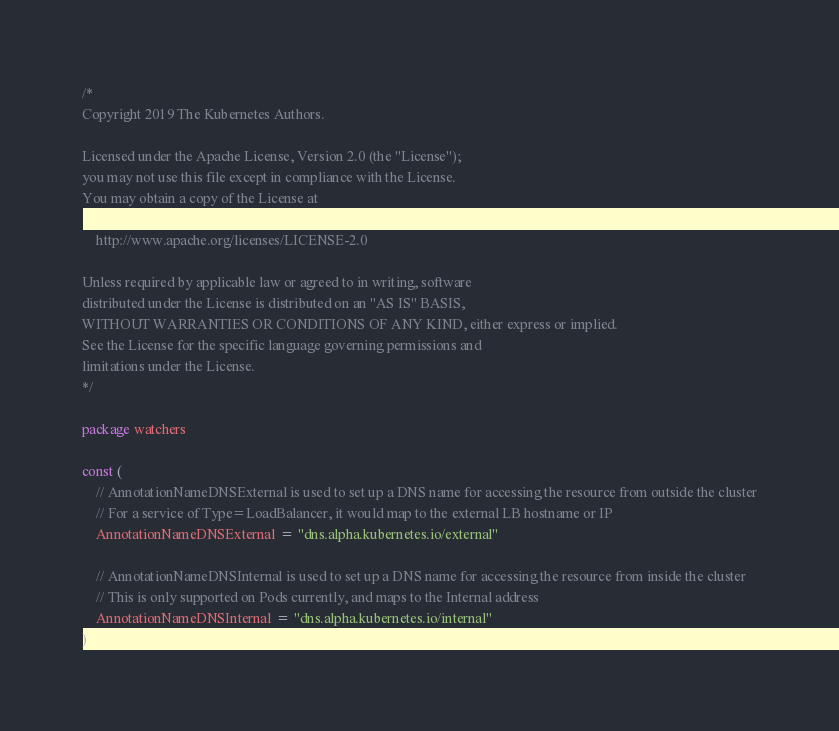Convert code to text. <code><loc_0><loc_0><loc_500><loc_500><_Go_>/*
Copyright 2019 The Kubernetes Authors.

Licensed under the Apache License, Version 2.0 (the "License");
you may not use this file except in compliance with the License.
You may obtain a copy of the License at

    http://www.apache.org/licenses/LICENSE-2.0

Unless required by applicable law or agreed to in writing, software
distributed under the License is distributed on an "AS IS" BASIS,
WITHOUT WARRANTIES OR CONDITIONS OF ANY KIND, either express or implied.
See the License for the specific language governing permissions and
limitations under the License.
*/

package watchers

const (
	// AnnotationNameDNSExternal is used to set up a DNS name for accessing the resource from outside the cluster
	// For a service of Type=LoadBalancer, it would map to the external LB hostname or IP
	AnnotationNameDNSExternal = "dns.alpha.kubernetes.io/external"

	// AnnotationNameDNSInternal is used to set up a DNS name for accessing the resource from inside the cluster
	// This is only supported on Pods currently, and maps to the Internal address
	AnnotationNameDNSInternal = "dns.alpha.kubernetes.io/internal"
)
</code> 